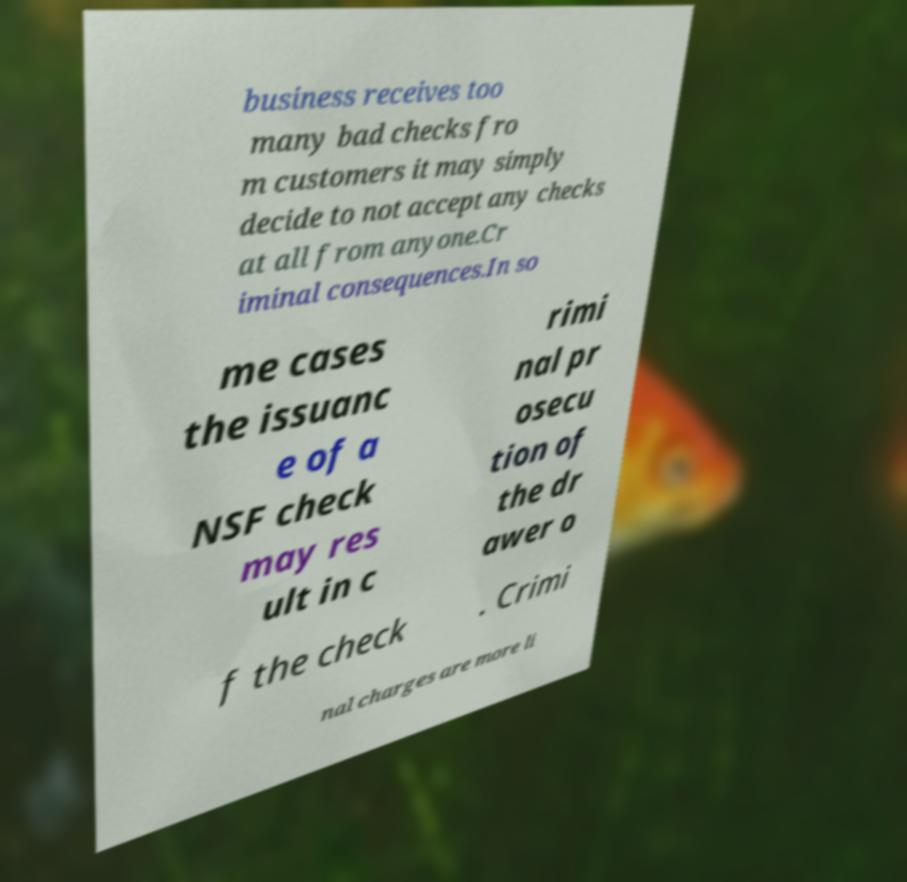There's text embedded in this image that I need extracted. Can you transcribe it verbatim? business receives too many bad checks fro m customers it may simply decide to not accept any checks at all from anyone.Cr iminal consequences.In so me cases the issuanc e of a NSF check may res ult in c rimi nal pr osecu tion of the dr awer o f the check . Crimi nal charges are more li 